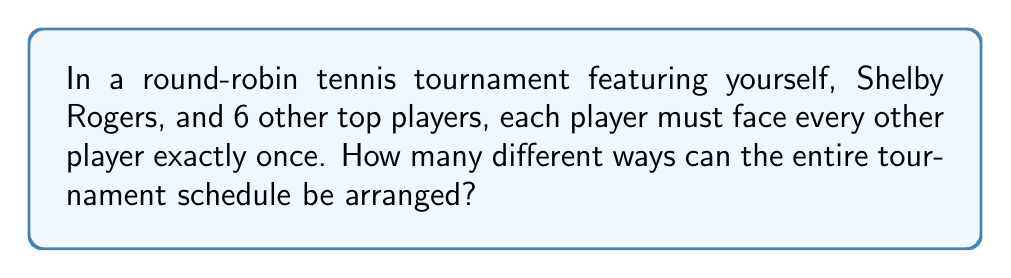Show me your answer to this math problem. Let's approach this step-by-step:

1) First, we need to calculate the total number of matches in the tournament:
   - There are 8 players in total
   - Each player plays 7 matches (against every other player)
   - Total matches = $(8 \times 7) / 2 = 28$ (divide by 2 to avoid counting each match twice)

2) Now, we need to consider how many ways we can arrange these 28 matches:
   - This is equivalent to the number of permutations of 28 objects
   - The formula for this is $28!$

3) However, the order of players within each match doesn't matter:
   - For each of the 28 matches, there are 2! ways to arrange the players
   - We need to divide our total by $(2!)^{28}$ to account for this

4) Therefore, the total number of possible schedules is:

   $$\frac{28!}{(2!)^{28}}$$

5) This can be simplified to:

   $$\frac{28!}{2^{28}}$$

This extremely large number represents all possible ways to schedule the matches in the tournament, including the ones where you face your admired competitor, Shelby Rogers.
Answer: $\frac{28!}{2^{28}}$ 